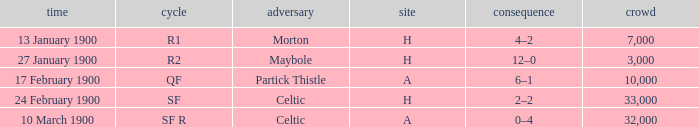What round did the celtic played away on 24 february 1900? SF. 